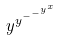<formula> <loc_0><loc_0><loc_500><loc_500>y ^ { y ^ { - ^ { - ^ { y ^ { x } } } } }</formula> 